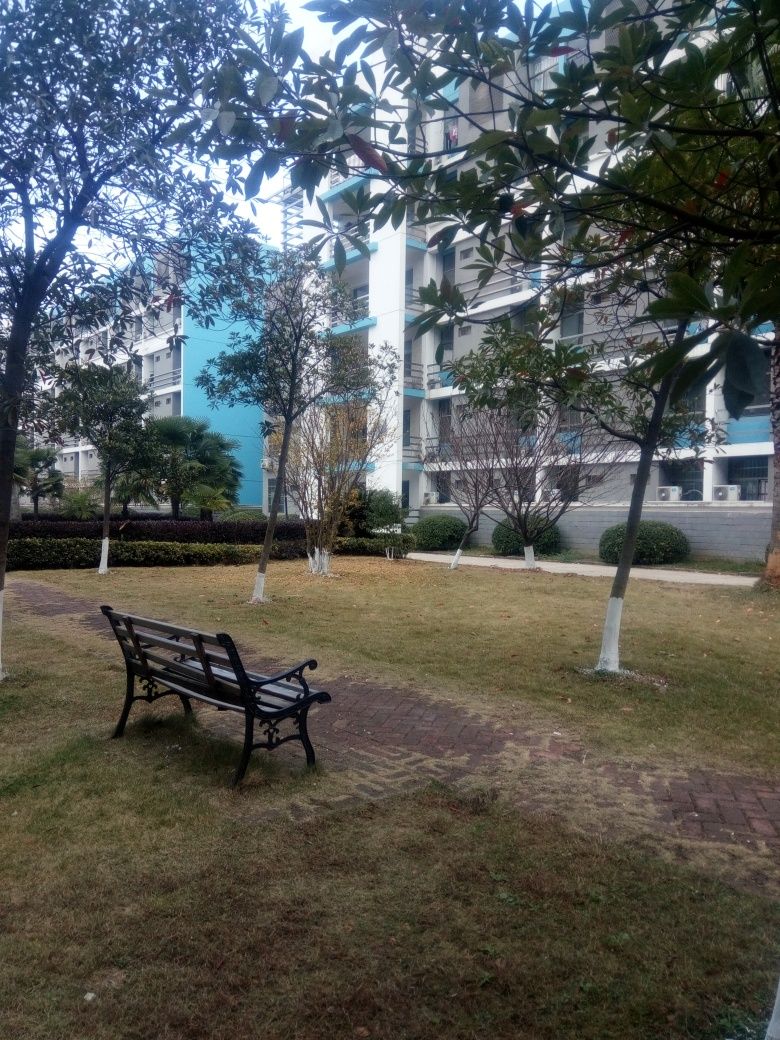What is the overall clarity of the image?
A. Acceptable
B. Poor
C. Blurry
Answer with the option's letter from the given choices directly.
 A. 